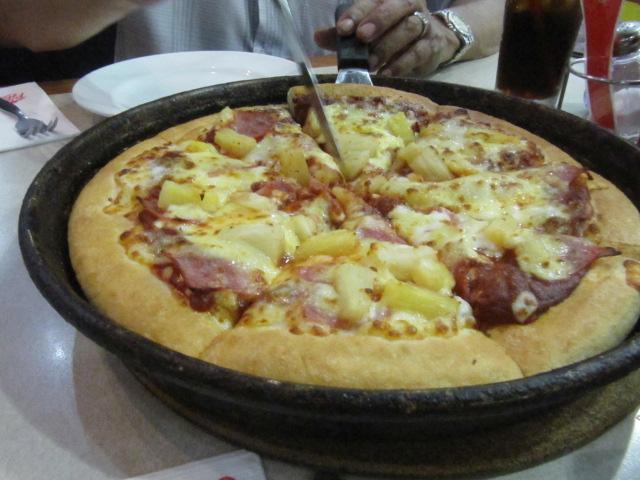How many slices of pizza are there?
Give a very brief answer. 8. Is this a Hawaiian?
Concise answer only. Yes. Is this healthy food?
Quick response, please. No. 